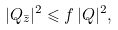Convert formula to latex. <formula><loc_0><loc_0><loc_500><loc_500>| Q _ { \bar { z } } | ^ { 2 } \leqslant f \, | Q | ^ { 2 } ,</formula> 